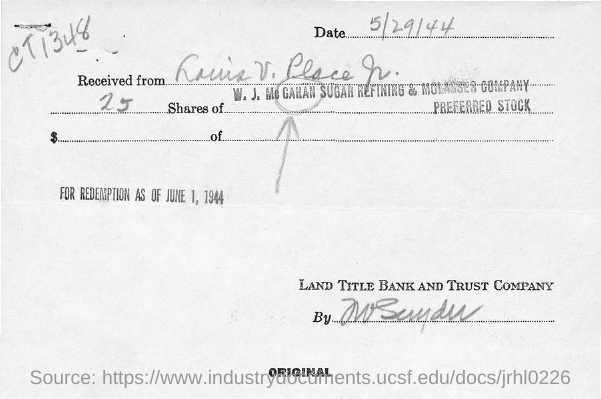List a handful of essential elements in this visual. The date for redemption is June 1, 1944. I have 25.... The shares are of the W. J. McGahan Sugar Refining & Molasses Company. Land Title Bank and Trust Company is mentioned at the bottom right corner of the document. The handwritten code on the top right corner is CT1348...," declared the witness. 